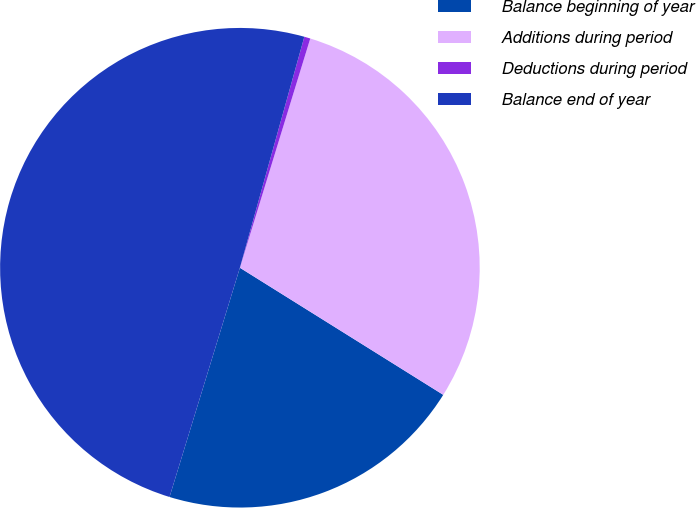Convert chart to OTSL. <chart><loc_0><loc_0><loc_500><loc_500><pie_chart><fcel>Balance beginning of year<fcel>Additions during period<fcel>Deductions during period<fcel>Balance end of year<nl><fcel>20.85%<fcel>29.15%<fcel>0.41%<fcel>49.59%<nl></chart> 